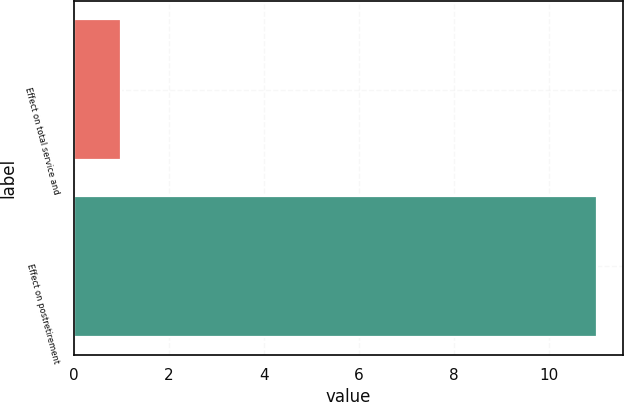Convert chart to OTSL. <chart><loc_0><loc_0><loc_500><loc_500><bar_chart><fcel>Effect on total service and<fcel>Effect on postretirement<nl><fcel>1<fcel>11<nl></chart> 